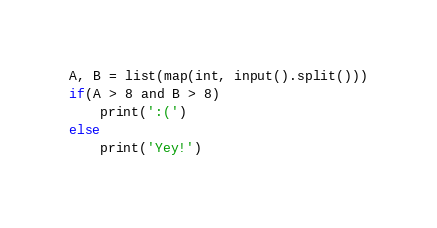Convert code to text. <code><loc_0><loc_0><loc_500><loc_500><_Python_>A, B = list(map(int, input().split()))
if(A > 8 and B > 8)
    print(':(')
else
    print('Yey!')
</code> 